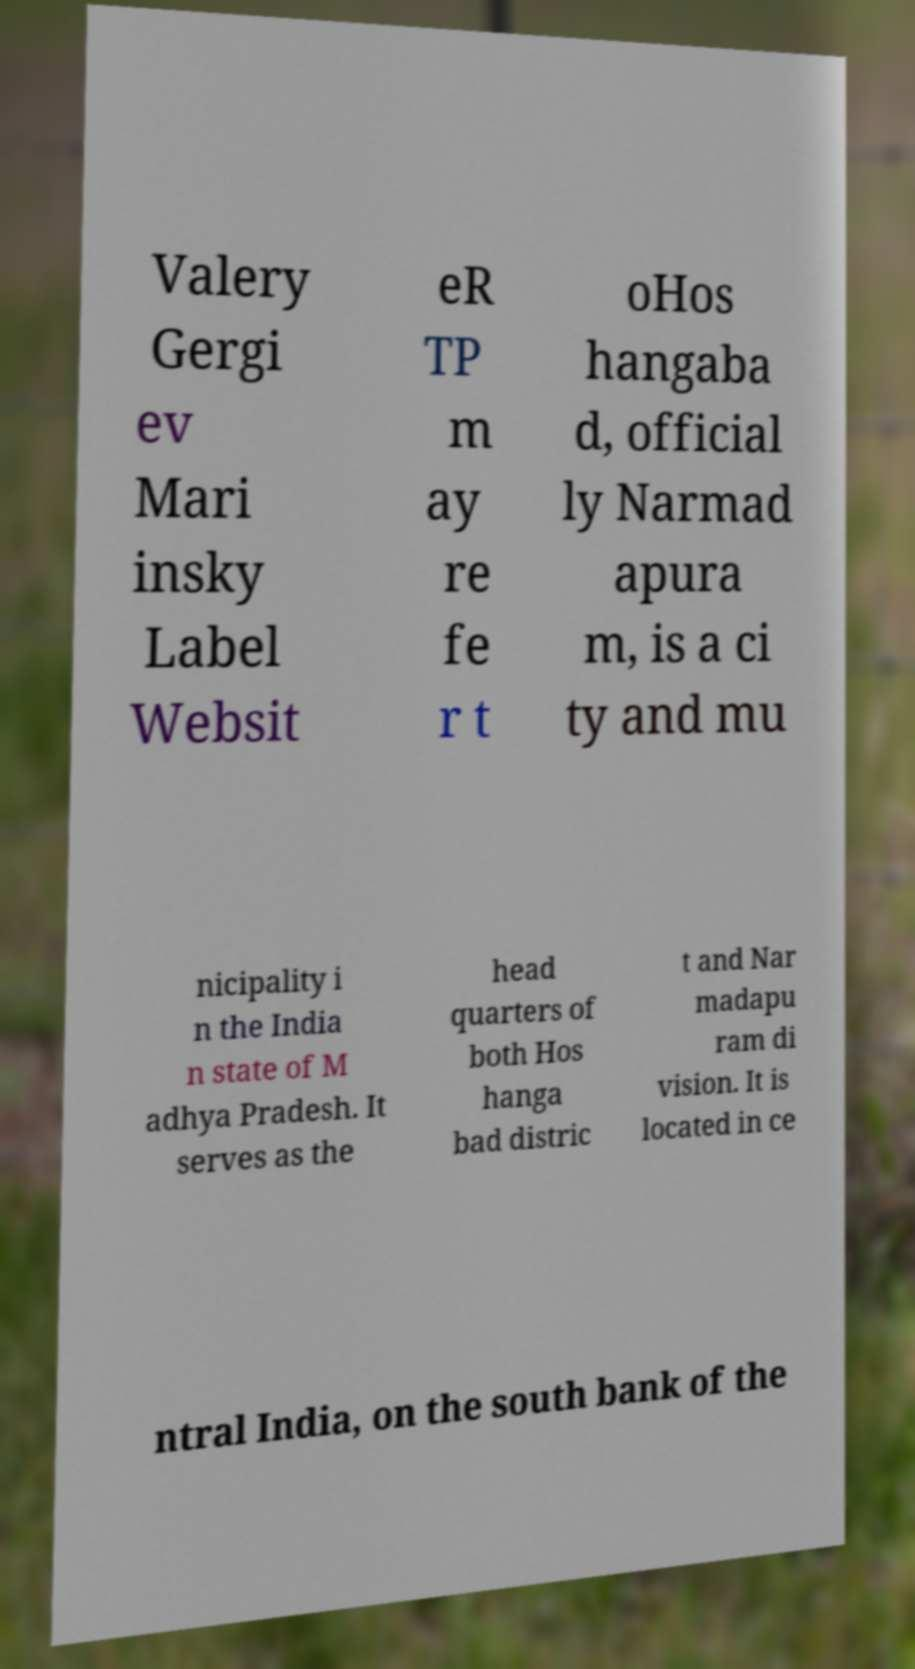Could you extract and type out the text from this image? Valery Gergi ev Mari insky Label Websit eR TP m ay re fe r t oHos hangaba d, official ly Narmad apura m, is a ci ty and mu nicipality i n the India n state of M adhya Pradesh. It serves as the head quarters of both Hos hanga bad distric t and Nar madapu ram di vision. It is located in ce ntral India, on the south bank of the 